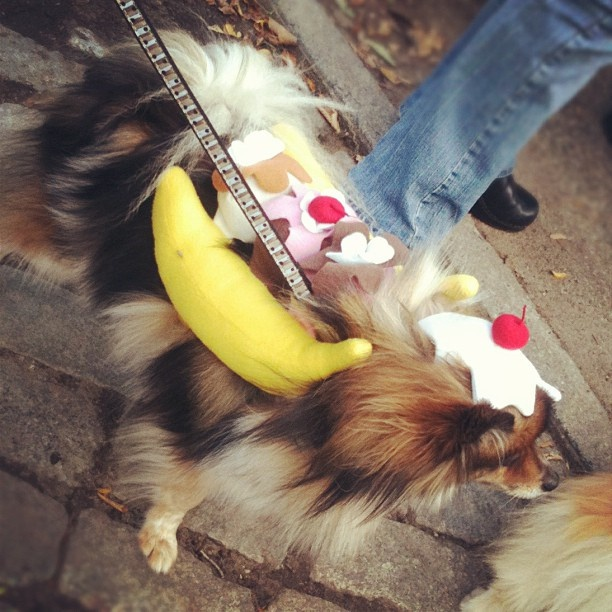Describe the objects in this image and their specific colors. I can see dog in black, ivory, gray, and tan tones, people in black, gray, and darkgray tones, banana in black, khaki, and olive tones, and dog in black, tan, and gray tones in this image. 